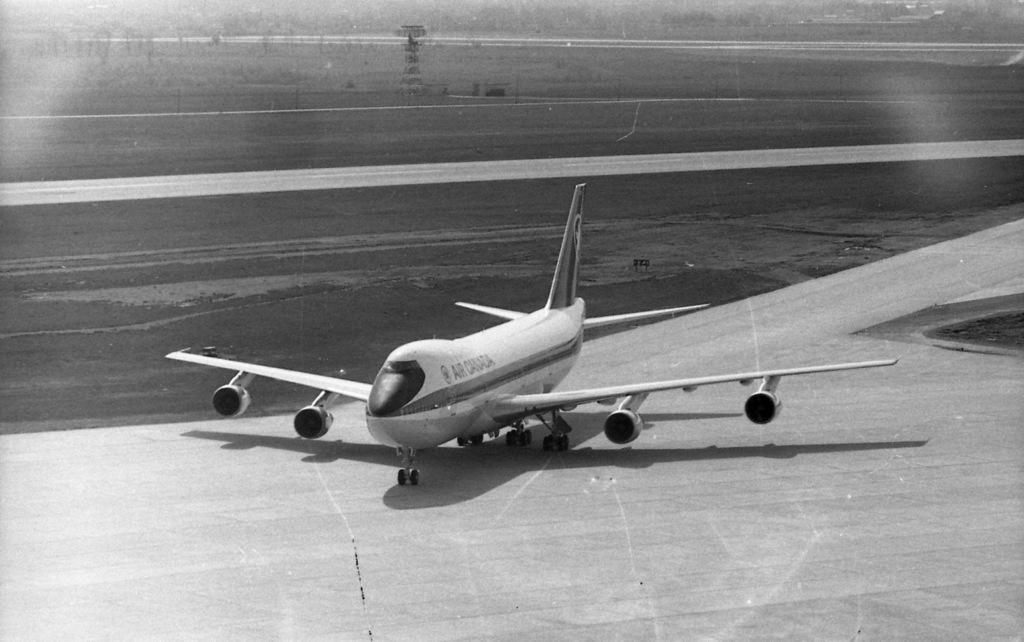Provide a one-sentence caption for the provided image. An Air Canada plane is on the runway. 